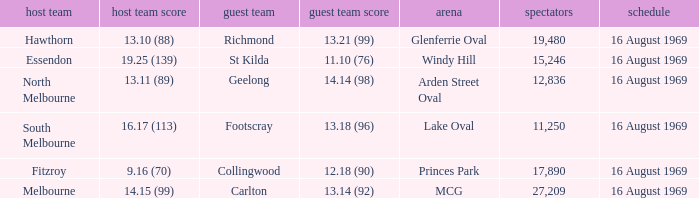What was the away team's score at Princes Park? 12.18 (90). 